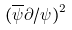<formula> <loc_0><loc_0><loc_500><loc_500>( \overline { \psi } \partial / \psi ) ^ { 2 }</formula> 